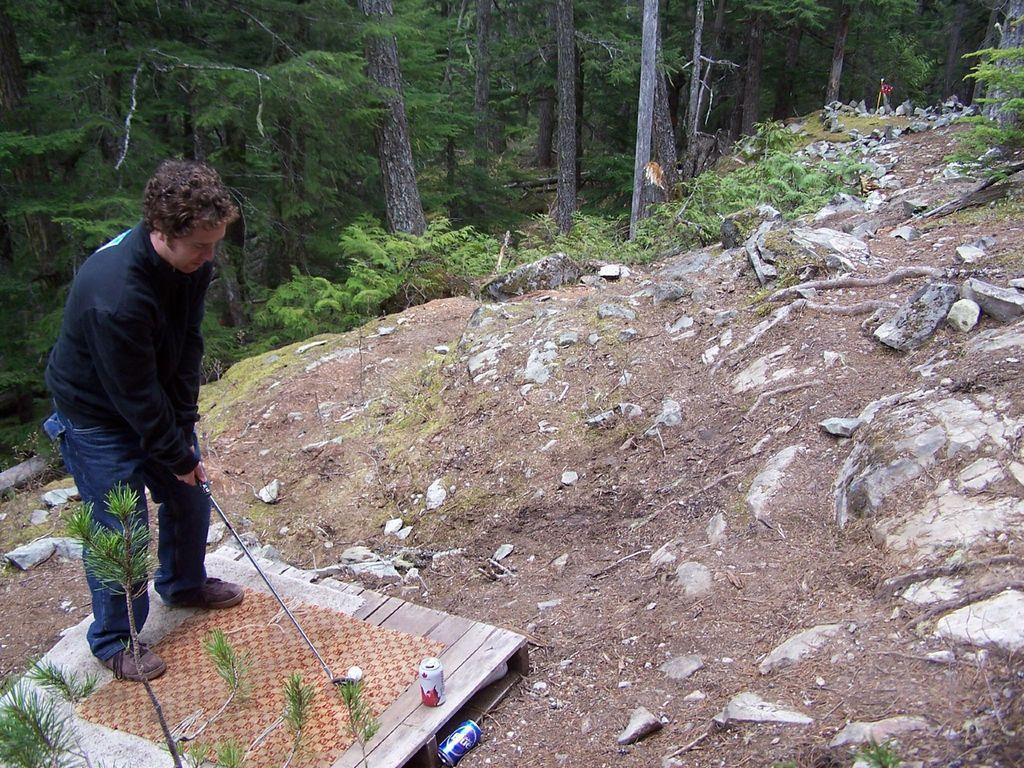How would you summarize this image in a sentence or two? In this image I can see a man is standing on a wooden board and holding a golf stick in hands. Here I can see a ball, tin cans and some other objects on the ground. In the background I can see trees, plants and the grass. 